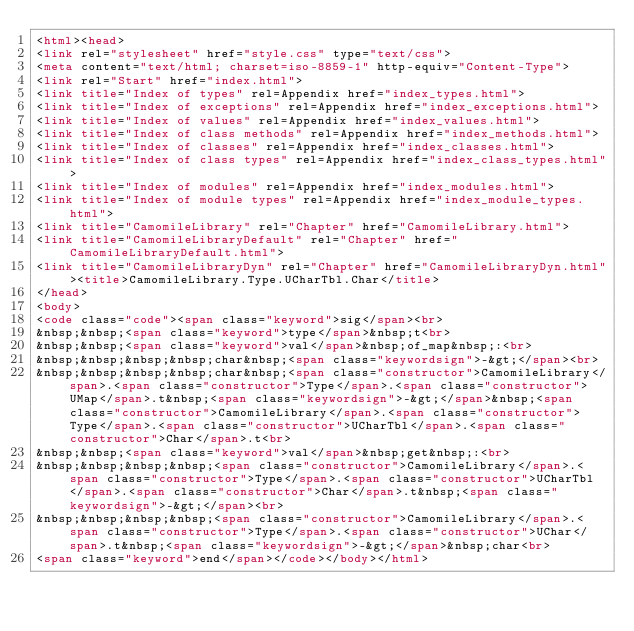Convert code to text. <code><loc_0><loc_0><loc_500><loc_500><_HTML_><html><head>
<link rel="stylesheet" href="style.css" type="text/css">
<meta content="text/html; charset=iso-8859-1" http-equiv="Content-Type">
<link rel="Start" href="index.html">
<link title="Index of types" rel=Appendix href="index_types.html">
<link title="Index of exceptions" rel=Appendix href="index_exceptions.html">
<link title="Index of values" rel=Appendix href="index_values.html">
<link title="Index of class methods" rel=Appendix href="index_methods.html">
<link title="Index of classes" rel=Appendix href="index_classes.html">
<link title="Index of class types" rel=Appendix href="index_class_types.html">
<link title="Index of modules" rel=Appendix href="index_modules.html">
<link title="Index of module types" rel=Appendix href="index_module_types.html">
<link title="CamomileLibrary" rel="Chapter" href="CamomileLibrary.html">
<link title="CamomileLibraryDefault" rel="Chapter" href="CamomileLibraryDefault.html">
<link title="CamomileLibraryDyn" rel="Chapter" href="CamomileLibraryDyn.html"><title>CamomileLibrary.Type.UCharTbl.Char</title>
</head>
<body>
<code class="code"><span class="keyword">sig</span><br>
&nbsp;&nbsp;<span class="keyword">type</span>&nbsp;t<br>
&nbsp;&nbsp;<span class="keyword">val</span>&nbsp;of_map&nbsp;:<br>
&nbsp;&nbsp;&nbsp;&nbsp;char&nbsp;<span class="keywordsign">-&gt;</span><br>
&nbsp;&nbsp;&nbsp;&nbsp;char&nbsp;<span class="constructor">CamomileLibrary</span>.<span class="constructor">Type</span>.<span class="constructor">UMap</span>.t&nbsp;<span class="keywordsign">-&gt;</span>&nbsp;<span class="constructor">CamomileLibrary</span>.<span class="constructor">Type</span>.<span class="constructor">UCharTbl</span>.<span class="constructor">Char</span>.t<br>
&nbsp;&nbsp;<span class="keyword">val</span>&nbsp;get&nbsp;:<br>
&nbsp;&nbsp;&nbsp;&nbsp;<span class="constructor">CamomileLibrary</span>.<span class="constructor">Type</span>.<span class="constructor">UCharTbl</span>.<span class="constructor">Char</span>.t&nbsp;<span class="keywordsign">-&gt;</span><br>
&nbsp;&nbsp;&nbsp;&nbsp;<span class="constructor">CamomileLibrary</span>.<span class="constructor">Type</span>.<span class="constructor">UChar</span>.t&nbsp;<span class="keywordsign">-&gt;</span>&nbsp;char<br>
<span class="keyword">end</span></code></body></html></code> 